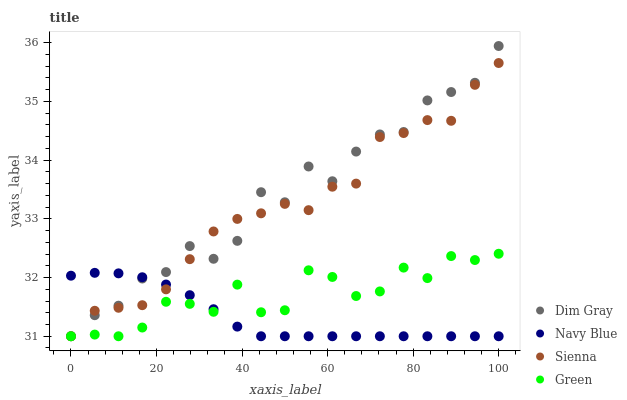Does Navy Blue have the minimum area under the curve?
Answer yes or no. Yes. Does Dim Gray have the maximum area under the curve?
Answer yes or no. Yes. Does Dim Gray have the minimum area under the curve?
Answer yes or no. No. Does Navy Blue have the maximum area under the curve?
Answer yes or no. No. Is Navy Blue the smoothest?
Answer yes or no. Yes. Is Dim Gray the roughest?
Answer yes or no. Yes. Is Dim Gray the smoothest?
Answer yes or no. No. Is Navy Blue the roughest?
Answer yes or no. No. Does Sienna have the lowest value?
Answer yes or no. Yes. Does Dim Gray have the highest value?
Answer yes or no. Yes. Does Navy Blue have the highest value?
Answer yes or no. No. Does Navy Blue intersect Green?
Answer yes or no. Yes. Is Navy Blue less than Green?
Answer yes or no. No. Is Navy Blue greater than Green?
Answer yes or no. No. 